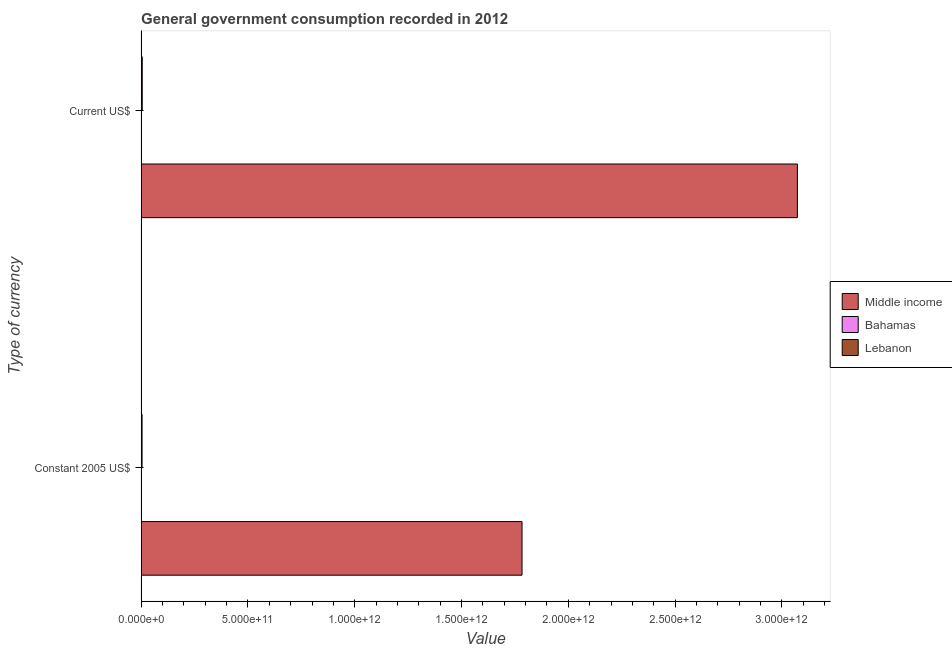How many different coloured bars are there?
Offer a terse response. 3. Are the number of bars per tick equal to the number of legend labels?
Offer a very short reply. Yes. Are the number of bars on each tick of the Y-axis equal?
Offer a very short reply. Yes. How many bars are there on the 1st tick from the bottom?
Keep it short and to the point. 3. What is the label of the 1st group of bars from the top?
Give a very brief answer. Current US$. What is the value consumed in constant 2005 us$ in Middle income?
Provide a succinct answer. 1.78e+12. Across all countries, what is the maximum value consumed in current us$?
Your response must be concise. 3.07e+12. Across all countries, what is the minimum value consumed in constant 2005 us$?
Offer a very short reply. 1.02e+09. In which country was the value consumed in current us$ maximum?
Offer a very short reply. Middle income. In which country was the value consumed in current us$ minimum?
Provide a short and direct response. Bahamas. What is the total value consumed in constant 2005 us$ in the graph?
Make the answer very short. 1.79e+12. What is the difference between the value consumed in constant 2005 us$ in Lebanon and that in Middle income?
Give a very brief answer. -1.78e+12. What is the difference between the value consumed in current us$ in Bahamas and the value consumed in constant 2005 us$ in Middle income?
Give a very brief answer. -1.78e+12. What is the average value consumed in current us$ per country?
Make the answer very short. 1.03e+12. What is the difference between the value consumed in constant 2005 us$ and value consumed in current us$ in Middle income?
Keep it short and to the point. -1.29e+12. What is the ratio of the value consumed in current us$ in Bahamas to that in Lebanon?
Provide a short and direct response. 0.25. Is the value consumed in constant 2005 us$ in Bahamas less than that in Lebanon?
Offer a terse response. Yes. In how many countries, is the value consumed in current us$ greater than the average value consumed in current us$ taken over all countries?
Your answer should be compact. 1. What does the 2nd bar from the top in Constant 2005 US$ represents?
Offer a very short reply. Bahamas. What does the 1st bar from the bottom in Constant 2005 US$ represents?
Offer a terse response. Middle income. How many countries are there in the graph?
Keep it short and to the point. 3. What is the difference between two consecutive major ticks on the X-axis?
Offer a very short reply. 5.00e+11. Are the values on the major ticks of X-axis written in scientific E-notation?
Provide a short and direct response. Yes. Does the graph contain any zero values?
Your answer should be very brief. No. Does the graph contain grids?
Your response must be concise. No. Where does the legend appear in the graph?
Provide a short and direct response. Center right. How many legend labels are there?
Your answer should be very brief. 3. How are the legend labels stacked?
Offer a very short reply. Vertical. What is the title of the graph?
Offer a very short reply. General government consumption recorded in 2012. What is the label or title of the X-axis?
Offer a terse response. Value. What is the label or title of the Y-axis?
Give a very brief answer. Type of currency. What is the Value of Middle income in Constant 2005 US$?
Keep it short and to the point. 1.78e+12. What is the Value of Bahamas in Constant 2005 US$?
Your response must be concise. 1.02e+09. What is the Value of Lebanon in Constant 2005 US$?
Your answer should be very brief. 4.33e+09. What is the Value in Middle income in Current US$?
Offer a terse response. 3.07e+12. What is the Value of Bahamas in Current US$?
Provide a succinct answer. 1.28e+09. What is the Value in Lebanon in Current US$?
Offer a very short reply. 5.17e+09. Across all Type of currency, what is the maximum Value of Middle income?
Give a very brief answer. 3.07e+12. Across all Type of currency, what is the maximum Value in Bahamas?
Keep it short and to the point. 1.28e+09. Across all Type of currency, what is the maximum Value of Lebanon?
Give a very brief answer. 5.17e+09. Across all Type of currency, what is the minimum Value in Middle income?
Your answer should be compact. 1.78e+12. Across all Type of currency, what is the minimum Value of Bahamas?
Your response must be concise. 1.02e+09. Across all Type of currency, what is the minimum Value of Lebanon?
Provide a short and direct response. 4.33e+09. What is the total Value in Middle income in the graph?
Ensure brevity in your answer.  4.86e+12. What is the total Value of Bahamas in the graph?
Offer a very short reply. 2.29e+09. What is the total Value in Lebanon in the graph?
Provide a succinct answer. 9.50e+09. What is the difference between the Value in Middle income in Constant 2005 US$ and that in Current US$?
Keep it short and to the point. -1.29e+12. What is the difference between the Value in Bahamas in Constant 2005 US$ and that in Current US$?
Offer a terse response. -2.62e+08. What is the difference between the Value in Lebanon in Constant 2005 US$ and that in Current US$?
Give a very brief answer. -8.38e+08. What is the difference between the Value of Middle income in Constant 2005 US$ and the Value of Bahamas in Current US$?
Provide a short and direct response. 1.78e+12. What is the difference between the Value of Middle income in Constant 2005 US$ and the Value of Lebanon in Current US$?
Your answer should be compact. 1.78e+12. What is the difference between the Value of Bahamas in Constant 2005 US$ and the Value of Lebanon in Current US$?
Offer a terse response. -4.15e+09. What is the average Value in Middle income per Type of currency?
Make the answer very short. 2.43e+12. What is the average Value in Bahamas per Type of currency?
Your response must be concise. 1.15e+09. What is the average Value of Lebanon per Type of currency?
Offer a very short reply. 4.75e+09. What is the difference between the Value in Middle income and Value in Bahamas in Constant 2005 US$?
Offer a terse response. 1.78e+12. What is the difference between the Value of Middle income and Value of Lebanon in Constant 2005 US$?
Offer a terse response. 1.78e+12. What is the difference between the Value in Bahamas and Value in Lebanon in Constant 2005 US$?
Provide a short and direct response. -3.31e+09. What is the difference between the Value of Middle income and Value of Bahamas in Current US$?
Keep it short and to the point. 3.07e+12. What is the difference between the Value in Middle income and Value in Lebanon in Current US$?
Ensure brevity in your answer.  3.07e+12. What is the difference between the Value of Bahamas and Value of Lebanon in Current US$?
Offer a very short reply. -3.89e+09. What is the ratio of the Value in Middle income in Constant 2005 US$ to that in Current US$?
Offer a terse response. 0.58. What is the ratio of the Value of Bahamas in Constant 2005 US$ to that in Current US$?
Keep it short and to the point. 0.79. What is the ratio of the Value in Lebanon in Constant 2005 US$ to that in Current US$?
Your response must be concise. 0.84. What is the difference between the highest and the second highest Value in Middle income?
Make the answer very short. 1.29e+12. What is the difference between the highest and the second highest Value of Bahamas?
Offer a very short reply. 2.62e+08. What is the difference between the highest and the second highest Value of Lebanon?
Offer a terse response. 8.38e+08. What is the difference between the highest and the lowest Value in Middle income?
Ensure brevity in your answer.  1.29e+12. What is the difference between the highest and the lowest Value of Bahamas?
Your answer should be very brief. 2.62e+08. What is the difference between the highest and the lowest Value of Lebanon?
Your answer should be compact. 8.38e+08. 